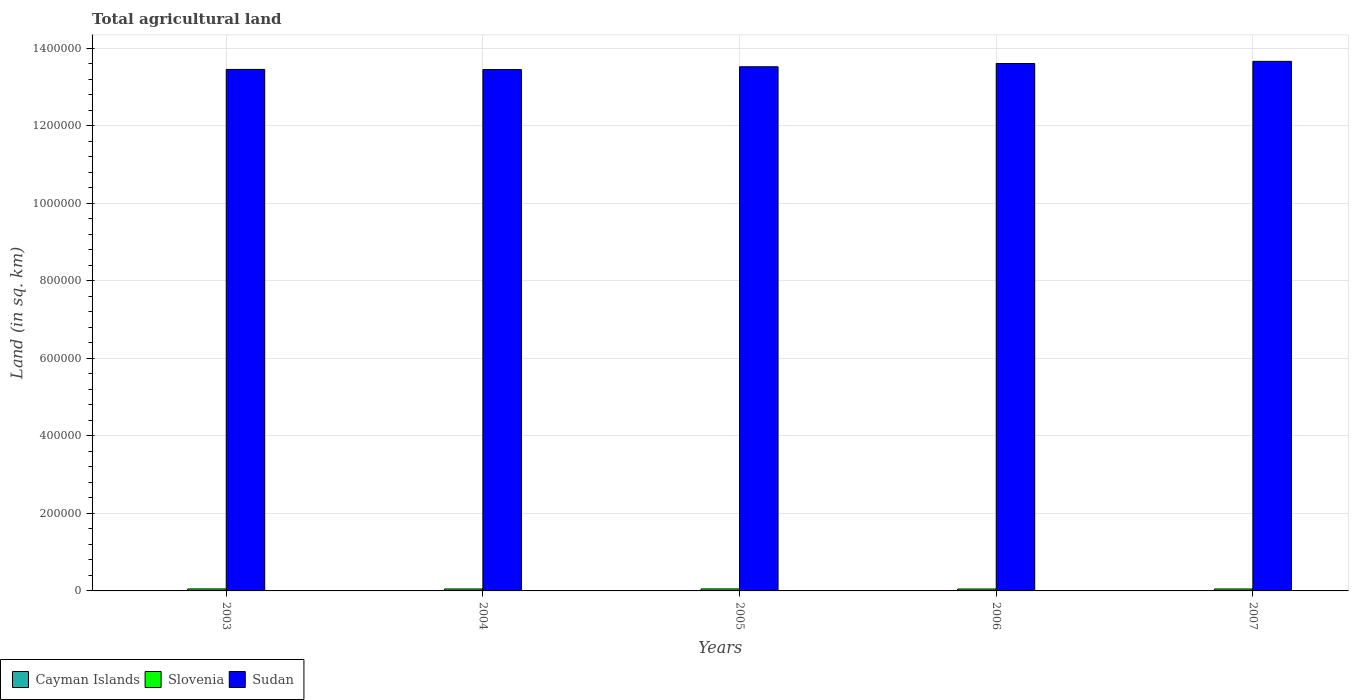How many different coloured bars are there?
Offer a very short reply. 3. Are the number of bars per tick equal to the number of legend labels?
Offer a terse response. Yes. Are the number of bars on each tick of the X-axis equal?
Offer a very short reply. Yes. What is the label of the 5th group of bars from the left?
Offer a terse response. 2007. What is the total agricultural land in Slovenia in 2005?
Offer a very short reply. 5090. Across all years, what is the maximum total agricultural land in Cayman Islands?
Offer a very short reply. 27. Across all years, what is the minimum total agricultural land in Cayman Islands?
Offer a very short reply. 27. What is the total total agricultural land in Cayman Islands in the graph?
Provide a short and direct response. 135. What is the difference between the total agricultural land in Slovenia in 2004 and that in 2006?
Provide a succinct answer. 10. What is the difference between the total agricultural land in Sudan in 2005 and the total agricultural land in Cayman Islands in 2003?
Your answer should be very brief. 1.35e+06. What is the average total agricultural land in Cayman Islands per year?
Your response must be concise. 27. In the year 2003, what is the difference between the total agricultural land in Cayman Islands and total agricultural land in Sudan?
Offer a terse response. -1.35e+06. What is the ratio of the total agricultural land in Cayman Islands in 2003 to that in 2004?
Your response must be concise. 1. Is the total agricultural land in Cayman Islands in 2003 less than that in 2007?
Make the answer very short. No. What is the difference between the highest and the second highest total agricultural land in Sudan?
Provide a succinct answer. 5620. What is the difference between the highest and the lowest total agricultural land in Slovenia?
Make the answer very short. 190. Is the sum of the total agricultural land in Sudan in 2004 and 2007 greater than the maximum total agricultural land in Cayman Islands across all years?
Give a very brief answer. Yes. What does the 3rd bar from the left in 2005 represents?
Provide a succinct answer. Sudan. What does the 1st bar from the right in 2006 represents?
Keep it short and to the point. Sudan. Where does the legend appear in the graph?
Make the answer very short. Bottom left. How are the legend labels stacked?
Your answer should be very brief. Horizontal. What is the title of the graph?
Your answer should be compact. Total agricultural land. Does "Panama" appear as one of the legend labels in the graph?
Offer a terse response. No. What is the label or title of the Y-axis?
Your response must be concise. Land (in sq. km). What is the Land (in sq. km) of Slovenia in 2003?
Provide a succinct answer. 5100. What is the Land (in sq. km) in Sudan in 2003?
Give a very brief answer. 1.35e+06. What is the Land (in sq. km) of Cayman Islands in 2004?
Keep it short and to the point. 27. What is the Land (in sq. km) of Slovenia in 2004?
Your answer should be compact. 4920. What is the Land (in sq. km) of Sudan in 2004?
Keep it short and to the point. 1.34e+06. What is the Land (in sq. km) of Cayman Islands in 2005?
Offer a very short reply. 27. What is the Land (in sq. km) in Slovenia in 2005?
Give a very brief answer. 5090. What is the Land (in sq. km) of Sudan in 2005?
Keep it short and to the point. 1.35e+06. What is the Land (in sq. km) of Slovenia in 2006?
Your answer should be very brief. 4910. What is the Land (in sq. km) of Sudan in 2006?
Ensure brevity in your answer.  1.36e+06. What is the Land (in sq. km) of Cayman Islands in 2007?
Offer a terse response. 27. What is the Land (in sq. km) of Slovenia in 2007?
Provide a short and direct response. 4980. What is the Land (in sq. km) of Sudan in 2007?
Provide a short and direct response. 1.37e+06. Across all years, what is the maximum Land (in sq. km) in Cayman Islands?
Give a very brief answer. 27. Across all years, what is the maximum Land (in sq. km) of Slovenia?
Offer a very short reply. 5100. Across all years, what is the maximum Land (in sq. km) of Sudan?
Make the answer very short. 1.37e+06. Across all years, what is the minimum Land (in sq. km) in Cayman Islands?
Make the answer very short. 27. Across all years, what is the minimum Land (in sq. km) of Slovenia?
Ensure brevity in your answer.  4910. Across all years, what is the minimum Land (in sq. km) in Sudan?
Offer a very short reply. 1.34e+06. What is the total Land (in sq. km) in Cayman Islands in the graph?
Provide a short and direct response. 135. What is the total Land (in sq. km) of Slovenia in the graph?
Your answer should be very brief. 2.50e+04. What is the total Land (in sq. km) of Sudan in the graph?
Your response must be concise. 6.77e+06. What is the difference between the Land (in sq. km) in Slovenia in 2003 and that in 2004?
Your response must be concise. 180. What is the difference between the Land (in sq. km) in Sudan in 2003 and that in 2004?
Offer a terse response. 330. What is the difference between the Land (in sq. km) of Cayman Islands in 2003 and that in 2005?
Offer a very short reply. 0. What is the difference between the Land (in sq. km) in Sudan in 2003 and that in 2005?
Provide a short and direct response. -6900. What is the difference between the Land (in sq. km) of Cayman Islands in 2003 and that in 2006?
Make the answer very short. 0. What is the difference between the Land (in sq. km) in Slovenia in 2003 and that in 2006?
Your answer should be compact. 190. What is the difference between the Land (in sq. km) in Sudan in 2003 and that in 2006?
Your response must be concise. -1.52e+04. What is the difference between the Land (in sq. km) in Slovenia in 2003 and that in 2007?
Your answer should be compact. 120. What is the difference between the Land (in sq. km) of Sudan in 2003 and that in 2007?
Offer a very short reply. -2.08e+04. What is the difference between the Land (in sq. km) in Slovenia in 2004 and that in 2005?
Your answer should be very brief. -170. What is the difference between the Land (in sq. km) of Sudan in 2004 and that in 2005?
Keep it short and to the point. -7230. What is the difference between the Land (in sq. km) of Sudan in 2004 and that in 2006?
Make the answer very short. -1.56e+04. What is the difference between the Land (in sq. km) in Slovenia in 2004 and that in 2007?
Provide a short and direct response. -60. What is the difference between the Land (in sq. km) in Sudan in 2004 and that in 2007?
Provide a short and direct response. -2.12e+04. What is the difference between the Land (in sq. km) in Cayman Islands in 2005 and that in 2006?
Provide a short and direct response. 0. What is the difference between the Land (in sq. km) of Slovenia in 2005 and that in 2006?
Offer a very short reply. 180. What is the difference between the Land (in sq. km) of Sudan in 2005 and that in 2006?
Provide a succinct answer. -8330. What is the difference between the Land (in sq. km) of Slovenia in 2005 and that in 2007?
Your answer should be very brief. 110. What is the difference between the Land (in sq. km) in Sudan in 2005 and that in 2007?
Your answer should be compact. -1.40e+04. What is the difference between the Land (in sq. km) of Slovenia in 2006 and that in 2007?
Your answer should be very brief. -70. What is the difference between the Land (in sq. km) of Sudan in 2006 and that in 2007?
Provide a short and direct response. -5620. What is the difference between the Land (in sq. km) of Cayman Islands in 2003 and the Land (in sq. km) of Slovenia in 2004?
Provide a succinct answer. -4893. What is the difference between the Land (in sq. km) in Cayman Islands in 2003 and the Land (in sq. km) in Sudan in 2004?
Your response must be concise. -1.34e+06. What is the difference between the Land (in sq. km) in Slovenia in 2003 and the Land (in sq. km) in Sudan in 2004?
Keep it short and to the point. -1.34e+06. What is the difference between the Land (in sq. km) in Cayman Islands in 2003 and the Land (in sq. km) in Slovenia in 2005?
Keep it short and to the point. -5063. What is the difference between the Land (in sq. km) in Cayman Islands in 2003 and the Land (in sq. km) in Sudan in 2005?
Give a very brief answer. -1.35e+06. What is the difference between the Land (in sq. km) of Slovenia in 2003 and the Land (in sq. km) of Sudan in 2005?
Keep it short and to the point. -1.35e+06. What is the difference between the Land (in sq. km) of Cayman Islands in 2003 and the Land (in sq. km) of Slovenia in 2006?
Provide a succinct answer. -4883. What is the difference between the Land (in sq. km) in Cayman Islands in 2003 and the Land (in sq. km) in Sudan in 2006?
Ensure brevity in your answer.  -1.36e+06. What is the difference between the Land (in sq. km) of Slovenia in 2003 and the Land (in sq. km) of Sudan in 2006?
Your response must be concise. -1.36e+06. What is the difference between the Land (in sq. km) of Cayman Islands in 2003 and the Land (in sq. km) of Slovenia in 2007?
Ensure brevity in your answer.  -4953. What is the difference between the Land (in sq. km) in Cayman Islands in 2003 and the Land (in sq. km) in Sudan in 2007?
Ensure brevity in your answer.  -1.37e+06. What is the difference between the Land (in sq. km) of Slovenia in 2003 and the Land (in sq. km) of Sudan in 2007?
Make the answer very short. -1.36e+06. What is the difference between the Land (in sq. km) of Cayman Islands in 2004 and the Land (in sq. km) of Slovenia in 2005?
Give a very brief answer. -5063. What is the difference between the Land (in sq. km) in Cayman Islands in 2004 and the Land (in sq. km) in Sudan in 2005?
Make the answer very short. -1.35e+06. What is the difference between the Land (in sq. km) of Slovenia in 2004 and the Land (in sq. km) of Sudan in 2005?
Give a very brief answer. -1.35e+06. What is the difference between the Land (in sq. km) in Cayman Islands in 2004 and the Land (in sq. km) in Slovenia in 2006?
Your answer should be very brief. -4883. What is the difference between the Land (in sq. km) in Cayman Islands in 2004 and the Land (in sq. km) in Sudan in 2006?
Keep it short and to the point. -1.36e+06. What is the difference between the Land (in sq. km) of Slovenia in 2004 and the Land (in sq. km) of Sudan in 2006?
Your response must be concise. -1.36e+06. What is the difference between the Land (in sq. km) of Cayman Islands in 2004 and the Land (in sq. km) of Slovenia in 2007?
Provide a succinct answer. -4953. What is the difference between the Land (in sq. km) of Cayman Islands in 2004 and the Land (in sq. km) of Sudan in 2007?
Your answer should be very brief. -1.37e+06. What is the difference between the Land (in sq. km) in Slovenia in 2004 and the Land (in sq. km) in Sudan in 2007?
Make the answer very short. -1.36e+06. What is the difference between the Land (in sq. km) in Cayman Islands in 2005 and the Land (in sq. km) in Slovenia in 2006?
Offer a terse response. -4883. What is the difference between the Land (in sq. km) of Cayman Islands in 2005 and the Land (in sq. km) of Sudan in 2006?
Ensure brevity in your answer.  -1.36e+06. What is the difference between the Land (in sq. km) in Slovenia in 2005 and the Land (in sq. km) in Sudan in 2006?
Your response must be concise. -1.36e+06. What is the difference between the Land (in sq. km) in Cayman Islands in 2005 and the Land (in sq. km) in Slovenia in 2007?
Provide a short and direct response. -4953. What is the difference between the Land (in sq. km) of Cayman Islands in 2005 and the Land (in sq. km) of Sudan in 2007?
Make the answer very short. -1.37e+06. What is the difference between the Land (in sq. km) in Slovenia in 2005 and the Land (in sq. km) in Sudan in 2007?
Offer a very short reply. -1.36e+06. What is the difference between the Land (in sq. km) in Cayman Islands in 2006 and the Land (in sq. km) in Slovenia in 2007?
Your response must be concise. -4953. What is the difference between the Land (in sq. km) in Cayman Islands in 2006 and the Land (in sq. km) in Sudan in 2007?
Make the answer very short. -1.37e+06. What is the difference between the Land (in sq. km) in Slovenia in 2006 and the Land (in sq. km) in Sudan in 2007?
Your answer should be compact. -1.36e+06. What is the average Land (in sq. km) in Sudan per year?
Your answer should be compact. 1.35e+06. In the year 2003, what is the difference between the Land (in sq. km) in Cayman Islands and Land (in sq. km) in Slovenia?
Provide a short and direct response. -5073. In the year 2003, what is the difference between the Land (in sq. km) in Cayman Islands and Land (in sq. km) in Sudan?
Provide a succinct answer. -1.35e+06. In the year 2003, what is the difference between the Land (in sq. km) in Slovenia and Land (in sq. km) in Sudan?
Provide a short and direct response. -1.34e+06. In the year 2004, what is the difference between the Land (in sq. km) of Cayman Islands and Land (in sq. km) of Slovenia?
Your answer should be very brief. -4893. In the year 2004, what is the difference between the Land (in sq. km) in Cayman Islands and Land (in sq. km) in Sudan?
Provide a succinct answer. -1.34e+06. In the year 2004, what is the difference between the Land (in sq. km) of Slovenia and Land (in sq. km) of Sudan?
Keep it short and to the point. -1.34e+06. In the year 2005, what is the difference between the Land (in sq. km) of Cayman Islands and Land (in sq. km) of Slovenia?
Keep it short and to the point. -5063. In the year 2005, what is the difference between the Land (in sq. km) of Cayman Islands and Land (in sq. km) of Sudan?
Ensure brevity in your answer.  -1.35e+06. In the year 2005, what is the difference between the Land (in sq. km) in Slovenia and Land (in sq. km) in Sudan?
Your answer should be very brief. -1.35e+06. In the year 2006, what is the difference between the Land (in sq. km) in Cayman Islands and Land (in sq. km) in Slovenia?
Your response must be concise. -4883. In the year 2006, what is the difference between the Land (in sq. km) in Cayman Islands and Land (in sq. km) in Sudan?
Make the answer very short. -1.36e+06. In the year 2006, what is the difference between the Land (in sq. km) in Slovenia and Land (in sq. km) in Sudan?
Provide a short and direct response. -1.36e+06. In the year 2007, what is the difference between the Land (in sq. km) in Cayman Islands and Land (in sq. km) in Slovenia?
Your response must be concise. -4953. In the year 2007, what is the difference between the Land (in sq. km) of Cayman Islands and Land (in sq. km) of Sudan?
Your response must be concise. -1.37e+06. In the year 2007, what is the difference between the Land (in sq. km) in Slovenia and Land (in sq. km) in Sudan?
Your response must be concise. -1.36e+06. What is the ratio of the Land (in sq. km) of Cayman Islands in 2003 to that in 2004?
Offer a terse response. 1. What is the ratio of the Land (in sq. km) of Slovenia in 2003 to that in 2004?
Your answer should be very brief. 1.04. What is the ratio of the Land (in sq. km) of Sudan in 2003 to that in 2004?
Keep it short and to the point. 1. What is the ratio of the Land (in sq. km) of Cayman Islands in 2003 to that in 2005?
Your response must be concise. 1. What is the ratio of the Land (in sq. km) of Slovenia in 2003 to that in 2006?
Your answer should be very brief. 1.04. What is the ratio of the Land (in sq. km) in Sudan in 2003 to that in 2006?
Your response must be concise. 0.99. What is the ratio of the Land (in sq. km) of Cayman Islands in 2003 to that in 2007?
Your answer should be compact. 1. What is the ratio of the Land (in sq. km) of Slovenia in 2003 to that in 2007?
Your response must be concise. 1.02. What is the ratio of the Land (in sq. km) of Sudan in 2003 to that in 2007?
Keep it short and to the point. 0.98. What is the ratio of the Land (in sq. km) in Cayman Islands in 2004 to that in 2005?
Keep it short and to the point. 1. What is the ratio of the Land (in sq. km) of Slovenia in 2004 to that in 2005?
Ensure brevity in your answer.  0.97. What is the ratio of the Land (in sq. km) in Sudan in 2004 to that in 2005?
Provide a short and direct response. 0.99. What is the ratio of the Land (in sq. km) of Cayman Islands in 2004 to that in 2006?
Offer a terse response. 1. What is the ratio of the Land (in sq. km) of Slovenia in 2004 to that in 2006?
Make the answer very short. 1. What is the ratio of the Land (in sq. km) of Slovenia in 2004 to that in 2007?
Make the answer very short. 0.99. What is the ratio of the Land (in sq. km) of Sudan in 2004 to that in 2007?
Your answer should be compact. 0.98. What is the ratio of the Land (in sq. km) of Cayman Islands in 2005 to that in 2006?
Provide a succinct answer. 1. What is the ratio of the Land (in sq. km) of Slovenia in 2005 to that in 2006?
Provide a succinct answer. 1.04. What is the ratio of the Land (in sq. km) of Sudan in 2005 to that in 2006?
Ensure brevity in your answer.  0.99. What is the ratio of the Land (in sq. km) in Cayman Islands in 2005 to that in 2007?
Your answer should be very brief. 1. What is the ratio of the Land (in sq. km) of Slovenia in 2005 to that in 2007?
Offer a very short reply. 1.02. What is the ratio of the Land (in sq. km) in Slovenia in 2006 to that in 2007?
Ensure brevity in your answer.  0.99. What is the ratio of the Land (in sq. km) in Sudan in 2006 to that in 2007?
Your answer should be very brief. 1. What is the difference between the highest and the second highest Land (in sq. km) in Sudan?
Your answer should be very brief. 5620. What is the difference between the highest and the lowest Land (in sq. km) of Cayman Islands?
Make the answer very short. 0. What is the difference between the highest and the lowest Land (in sq. km) of Slovenia?
Ensure brevity in your answer.  190. What is the difference between the highest and the lowest Land (in sq. km) of Sudan?
Give a very brief answer. 2.12e+04. 